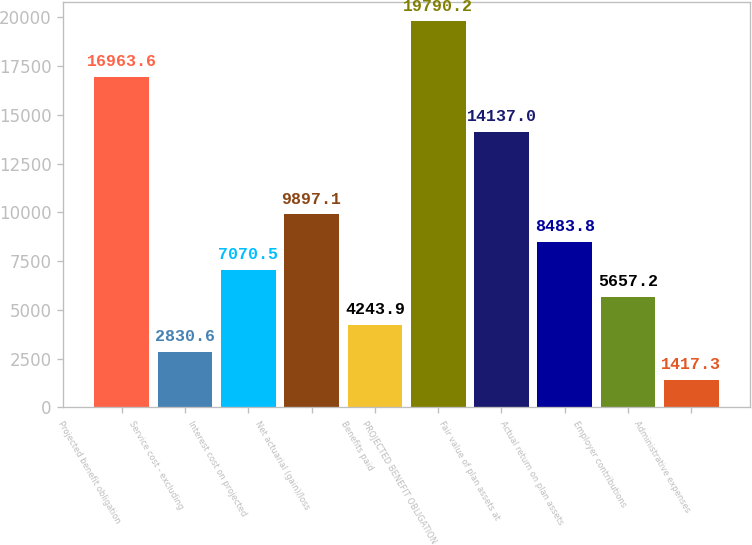<chart> <loc_0><loc_0><loc_500><loc_500><bar_chart><fcel>Projected benefit obligation<fcel>Service cost - excluding<fcel>Interest cost on projected<fcel>Net actuarial (gain)/loss<fcel>Benefits paid<fcel>PROJECTED BENEFIT OBLIGATION<fcel>Fair value of plan assets at<fcel>Actual return on plan assets<fcel>Employer contributions<fcel>Administrative expenses<nl><fcel>16963.6<fcel>2830.6<fcel>7070.5<fcel>9897.1<fcel>4243.9<fcel>19790.2<fcel>14137<fcel>8483.8<fcel>5657.2<fcel>1417.3<nl></chart> 